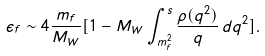Convert formula to latex. <formula><loc_0><loc_0><loc_500><loc_500>\epsilon _ { f } \sim 4 \frac { m _ { f } } { M _ { W } } [ 1 - M _ { W } \int _ { m ^ { 2 } _ { f } } ^ { s } \frac { \rho ( q ^ { 2 } ) } { q } \, d q ^ { 2 } ] .</formula> 